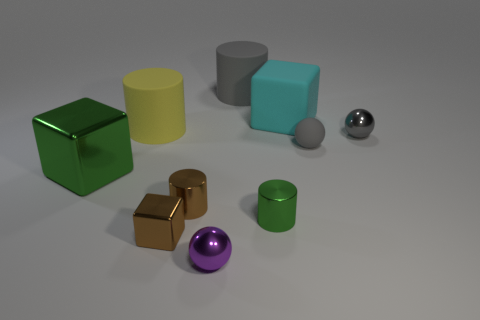Subtract all big blocks. How many blocks are left? 1 Subtract all green cylinders. How many cylinders are left? 3 Subtract all cubes. How many objects are left? 7 Subtract all brown cubes. How many yellow cylinders are left? 1 Subtract all tiny red matte things. Subtract all cyan matte things. How many objects are left? 9 Add 3 gray spheres. How many gray spheres are left? 5 Add 7 brown metal balls. How many brown metal balls exist? 7 Subtract 0 yellow spheres. How many objects are left? 10 Subtract 2 spheres. How many spheres are left? 1 Subtract all gray cylinders. Subtract all red blocks. How many cylinders are left? 3 